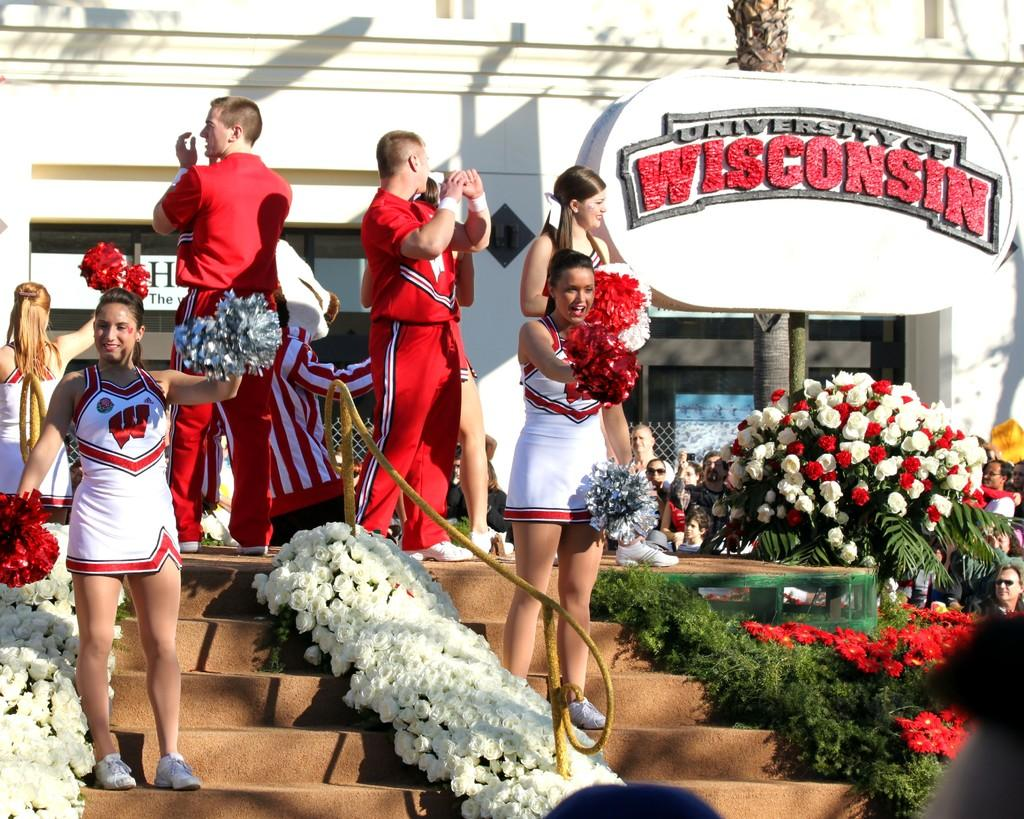<image>
Write a terse but informative summary of the picture. The school kids are cheering in front of a Wisconsin sign. 